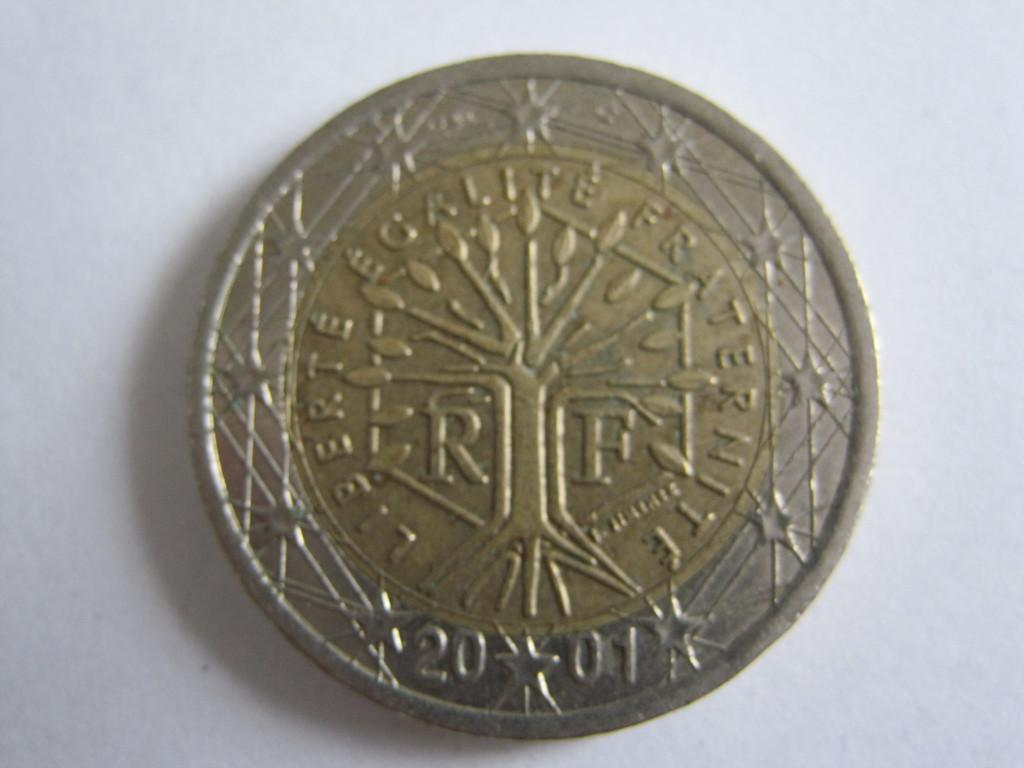<image>
Write a terse but informative summary of the picture. A small bronze colored coin with the word Liberte. 